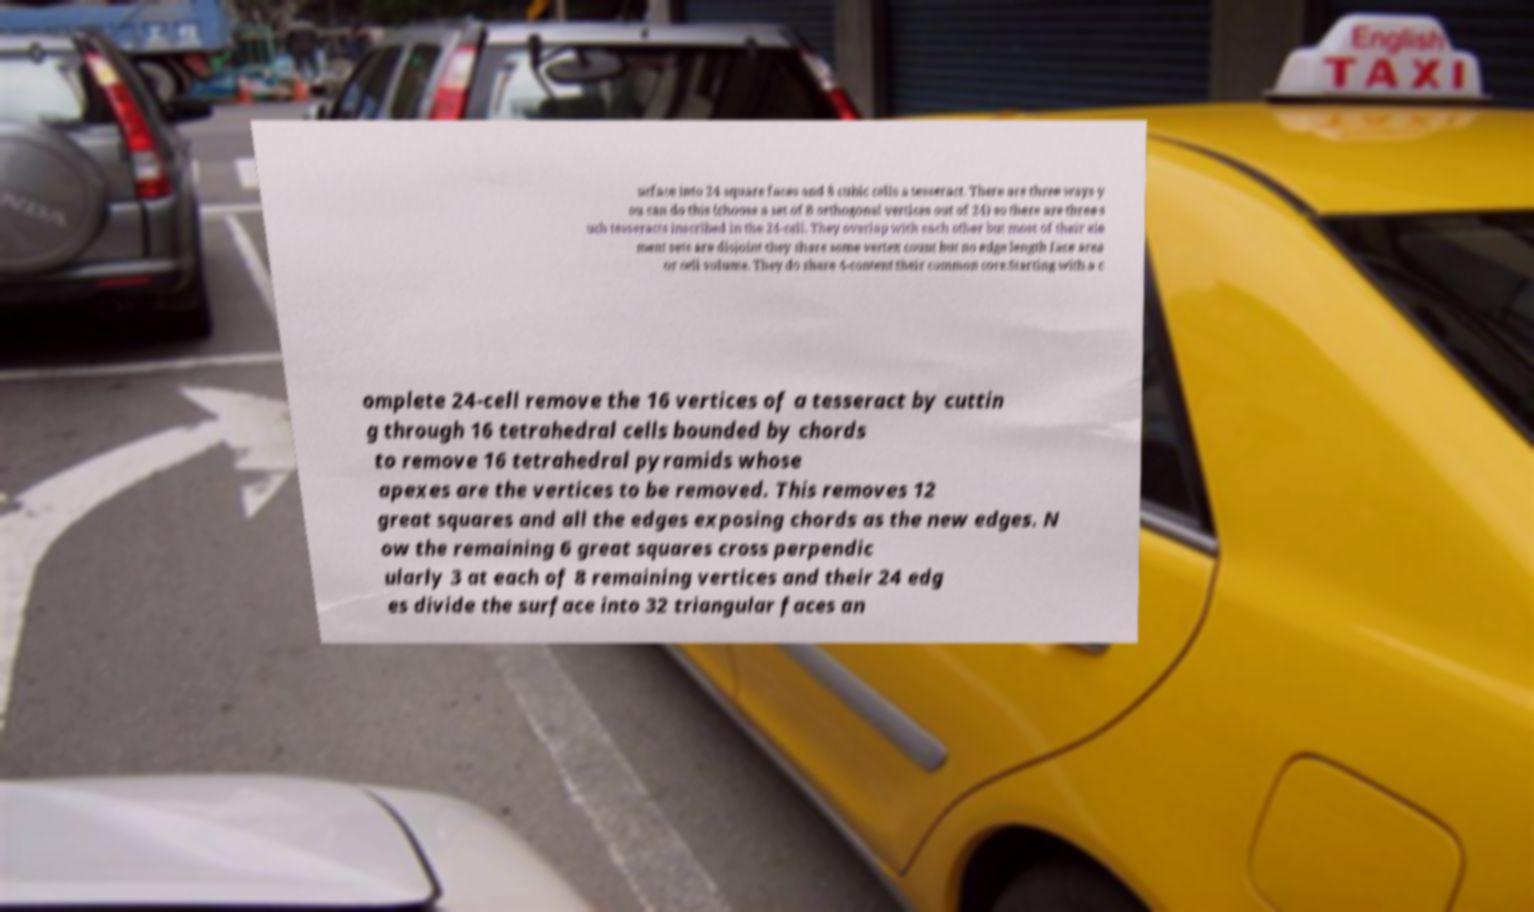Can you accurately transcribe the text from the provided image for me? urface into 24 square faces and 8 cubic cells a tesseract. There are three ways y ou can do this (choose a set of 8 orthogonal vertices out of 24) so there are three s uch tesseracts inscribed in the 24-cell. They overlap with each other but most of their ele ment sets are disjoint they share some vertex count but no edge length face area or cell volume. They do share 4-content their common core.Starting with a c omplete 24-cell remove the 16 vertices of a tesseract by cuttin g through 16 tetrahedral cells bounded by chords to remove 16 tetrahedral pyramids whose apexes are the vertices to be removed. This removes 12 great squares and all the edges exposing chords as the new edges. N ow the remaining 6 great squares cross perpendic ularly 3 at each of 8 remaining vertices and their 24 edg es divide the surface into 32 triangular faces an 